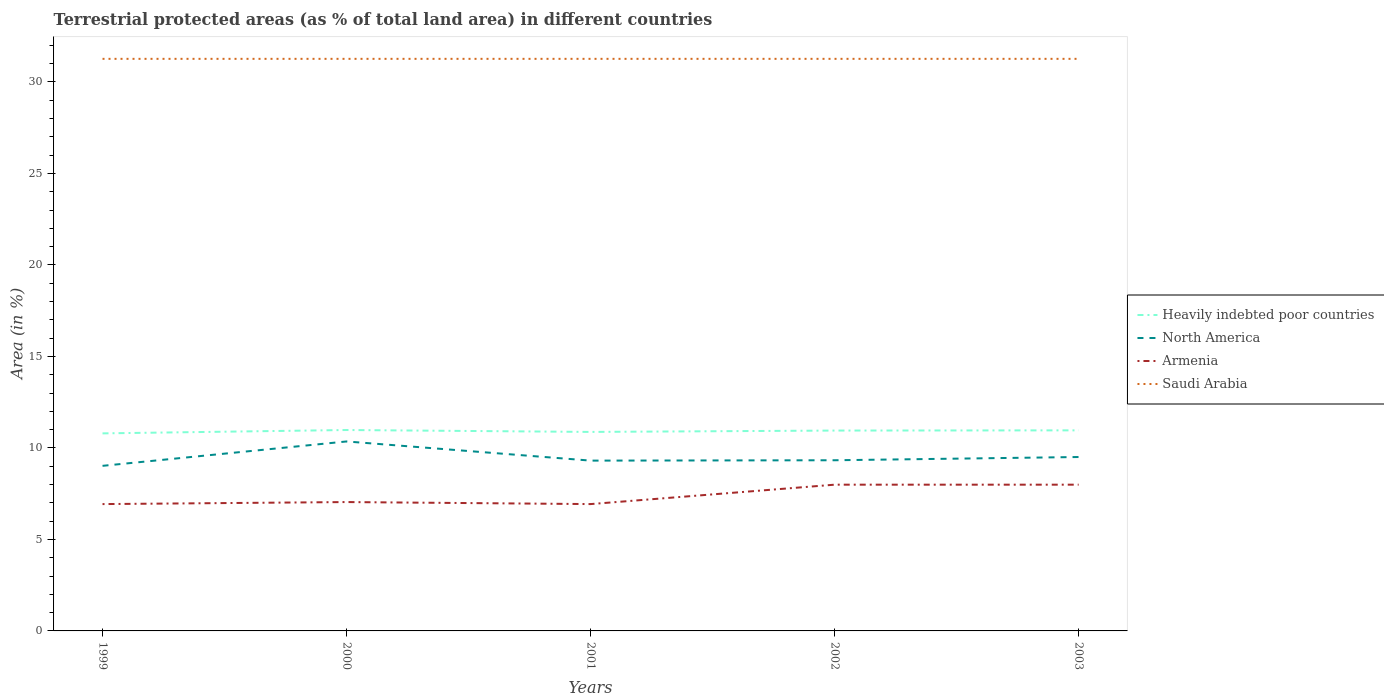Does the line corresponding to North America intersect with the line corresponding to Saudi Arabia?
Your answer should be compact. No. Across all years, what is the maximum percentage of terrestrial protected land in Saudi Arabia?
Provide a succinct answer. 31.26. What is the total percentage of terrestrial protected land in Saudi Arabia in the graph?
Offer a very short reply. 0. What is the difference between the highest and the second highest percentage of terrestrial protected land in Armenia?
Offer a very short reply. 1.06. Is the percentage of terrestrial protected land in Armenia strictly greater than the percentage of terrestrial protected land in Saudi Arabia over the years?
Ensure brevity in your answer.  Yes. How many years are there in the graph?
Provide a succinct answer. 5. Does the graph contain grids?
Your response must be concise. No. What is the title of the graph?
Your answer should be very brief. Terrestrial protected areas (as % of total land area) in different countries. Does "United Arab Emirates" appear as one of the legend labels in the graph?
Provide a succinct answer. No. What is the label or title of the Y-axis?
Provide a succinct answer. Area (in %). What is the Area (in %) in Heavily indebted poor countries in 1999?
Your answer should be compact. 10.8. What is the Area (in %) in North America in 1999?
Offer a terse response. 9.02. What is the Area (in %) of Armenia in 1999?
Provide a succinct answer. 6.93. What is the Area (in %) of Saudi Arabia in 1999?
Provide a short and direct response. 31.26. What is the Area (in %) in Heavily indebted poor countries in 2000?
Provide a succinct answer. 10.98. What is the Area (in %) in North America in 2000?
Provide a succinct answer. 10.35. What is the Area (in %) of Armenia in 2000?
Your answer should be very brief. 7.04. What is the Area (in %) in Saudi Arabia in 2000?
Your answer should be very brief. 31.26. What is the Area (in %) of Heavily indebted poor countries in 2001?
Your response must be concise. 10.87. What is the Area (in %) in North America in 2001?
Provide a short and direct response. 9.31. What is the Area (in %) of Armenia in 2001?
Keep it short and to the point. 6.93. What is the Area (in %) in Saudi Arabia in 2001?
Make the answer very short. 31.26. What is the Area (in %) in Heavily indebted poor countries in 2002?
Provide a succinct answer. 10.95. What is the Area (in %) of North America in 2002?
Ensure brevity in your answer.  9.33. What is the Area (in %) in Armenia in 2002?
Provide a short and direct response. 7.99. What is the Area (in %) of Saudi Arabia in 2002?
Ensure brevity in your answer.  31.26. What is the Area (in %) of Heavily indebted poor countries in 2003?
Keep it short and to the point. 10.96. What is the Area (in %) in North America in 2003?
Your response must be concise. 9.5. What is the Area (in %) of Armenia in 2003?
Your answer should be compact. 7.99. What is the Area (in %) of Saudi Arabia in 2003?
Your answer should be very brief. 31.26. Across all years, what is the maximum Area (in %) in Heavily indebted poor countries?
Provide a succinct answer. 10.98. Across all years, what is the maximum Area (in %) in North America?
Offer a very short reply. 10.35. Across all years, what is the maximum Area (in %) of Armenia?
Keep it short and to the point. 7.99. Across all years, what is the maximum Area (in %) in Saudi Arabia?
Make the answer very short. 31.26. Across all years, what is the minimum Area (in %) in Heavily indebted poor countries?
Your answer should be compact. 10.8. Across all years, what is the minimum Area (in %) in North America?
Make the answer very short. 9.02. Across all years, what is the minimum Area (in %) of Armenia?
Provide a succinct answer. 6.93. Across all years, what is the minimum Area (in %) in Saudi Arabia?
Your answer should be compact. 31.26. What is the total Area (in %) of Heavily indebted poor countries in the graph?
Offer a terse response. 54.56. What is the total Area (in %) of North America in the graph?
Give a very brief answer. 47.51. What is the total Area (in %) in Armenia in the graph?
Ensure brevity in your answer.  36.89. What is the total Area (in %) of Saudi Arabia in the graph?
Provide a succinct answer. 156.31. What is the difference between the Area (in %) of Heavily indebted poor countries in 1999 and that in 2000?
Give a very brief answer. -0.18. What is the difference between the Area (in %) of North America in 1999 and that in 2000?
Your answer should be very brief. -1.33. What is the difference between the Area (in %) of Armenia in 1999 and that in 2000?
Your answer should be very brief. -0.11. What is the difference between the Area (in %) of Saudi Arabia in 1999 and that in 2000?
Offer a terse response. -0. What is the difference between the Area (in %) in Heavily indebted poor countries in 1999 and that in 2001?
Your answer should be very brief. -0.08. What is the difference between the Area (in %) in North America in 1999 and that in 2001?
Ensure brevity in your answer.  -0.29. What is the difference between the Area (in %) of Armenia in 1999 and that in 2001?
Ensure brevity in your answer.  0. What is the difference between the Area (in %) in Heavily indebted poor countries in 1999 and that in 2002?
Provide a short and direct response. -0.15. What is the difference between the Area (in %) in North America in 1999 and that in 2002?
Offer a terse response. -0.31. What is the difference between the Area (in %) in Armenia in 1999 and that in 2002?
Make the answer very short. -1.06. What is the difference between the Area (in %) of Heavily indebted poor countries in 1999 and that in 2003?
Give a very brief answer. -0.17. What is the difference between the Area (in %) of North America in 1999 and that in 2003?
Give a very brief answer. -0.48. What is the difference between the Area (in %) of Armenia in 1999 and that in 2003?
Offer a terse response. -1.06. What is the difference between the Area (in %) of Heavily indebted poor countries in 2000 and that in 2001?
Provide a short and direct response. 0.1. What is the difference between the Area (in %) in North America in 2000 and that in 2001?
Keep it short and to the point. 1.05. What is the difference between the Area (in %) in Armenia in 2000 and that in 2001?
Ensure brevity in your answer.  0.11. What is the difference between the Area (in %) of Heavily indebted poor countries in 2000 and that in 2002?
Your response must be concise. 0.03. What is the difference between the Area (in %) in North America in 2000 and that in 2002?
Your answer should be very brief. 1.03. What is the difference between the Area (in %) of Armenia in 2000 and that in 2002?
Make the answer very short. -0.95. What is the difference between the Area (in %) in Heavily indebted poor countries in 2000 and that in 2003?
Give a very brief answer. 0.02. What is the difference between the Area (in %) of North America in 2000 and that in 2003?
Keep it short and to the point. 0.85. What is the difference between the Area (in %) of Armenia in 2000 and that in 2003?
Keep it short and to the point. -0.95. What is the difference between the Area (in %) of Heavily indebted poor countries in 2001 and that in 2002?
Your answer should be compact. -0.07. What is the difference between the Area (in %) in North America in 2001 and that in 2002?
Your answer should be compact. -0.02. What is the difference between the Area (in %) of Armenia in 2001 and that in 2002?
Provide a short and direct response. -1.06. What is the difference between the Area (in %) in Saudi Arabia in 2001 and that in 2002?
Keep it short and to the point. 0. What is the difference between the Area (in %) of Heavily indebted poor countries in 2001 and that in 2003?
Offer a very short reply. -0.09. What is the difference between the Area (in %) of North America in 2001 and that in 2003?
Give a very brief answer. -0.2. What is the difference between the Area (in %) of Armenia in 2001 and that in 2003?
Your answer should be compact. -1.06. What is the difference between the Area (in %) of Heavily indebted poor countries in 2002 and that in 2003?
Provide a short and direct response. -0.01. What is the difference between the Area (in %) in North America in 2002 and that in 2003?
Make the answer very short. -0.18. What is the difference between the Area (in %) of Heavily indebted poor countries in 1999 and the Area (in %) of North America in 2000?
Offer a terse response. 0.44. What is the difference between the Area (in %) of Heavily indebted poor countries in 1999 and the Area (in %) of Armenia in 2000?
Give a very brief answer. 3.75. What is the difference between the Area (in %) of Heavily indebted poor countries in 1999 and the Area (in %) of Saudi Arabia in 2000?
Provide a short and direct response. -20.47. What is the difference between the Area (in %) in North America in 1999 and the Area (in %) in Armenia in 2000?
Your response must be concise. 1.98. What is the difference between the Area (in %) of North America in 1999 and the Area (in %) of Saudi Arabia in 2000?
Make the answer very short. -22.24. What is the difference between the Area (in %) of Armenia in 1999 and the Area (in %) of Saudi Arabia in 2000?
Ensure brevity in your answer.  -24.33. What is the difference between the Area (in %) in Heavily indebted poor countries in 1999 and the Area (in %) in North America in 2001?
Give a very brief answer. 1.49. What is the difference between the Area (in %) of Heavily indebted poor countries in 1999 and the Area (in %) of Armenia in 2001?
Give a very brief answer. 3.86. What is the difference between the Area (in %) in Heavily indebted poor countries in 1999 and the Area (in %) in Saudi Arabia in 2001?
Make the answer very short. -20.47. What is the difference between the Area (in %) of North America in 1999 and the Area (in %) of Armenia in 2001?
Your answer should be very brief. 2.09. What is the difference between the Area (in %) of North America in 1999 and the Area (in %) of Saudi Arabia in 2001?
Provide a succinct answer. -22.24. What is the difference between the Area (in %) of Armenia in 1999 and the Area (in %) of Saudi Arabia in 2001?
Give a very brief answer. -24.33. What is the difference between the Area (in %) of Heavily indebted poor countries in 1999 and the Area (in %) of North America in 2002?
Ensure brevity in your answer.  1.47. What is the difference between the Area (in %) of Heavily indebted poor countries in 1999 and the Area (in %) of Armenia in 2002?
Make the answer very short. 2.8. What is the difference between the Area (in %) of Heavily indebted poor countries in 1999 and the Area (in %) of Saudi Arabia in 2002?
Give a very brief answer. -20.47. What is the difference between the Area (in %) in North America in 1999 and the Area (in %) in Armenia in 2002?
Your response must be concise. 1.03. What is the difference between the Area (in %) of North America in 1999 and the Area (in %) of Saudi Arabia in 2002?
Keep it short and to the point. -22.24. What is the difference between the Area (in %) of Armenia in 1999 and the Area (in %) of Saudi Arabia in 2002?
Your answer should be compact. -24.33. What is the difference between the Area (in %) of Heavily indebted poor countries in 1999 and the Area (in %) of North America in 2003?
Give a very brief answer. 1.29. What is the difference between the Area (in %) of Heavily indebted poor countries in 1999 and the Area (in %) of Armenia in 2003?
Your answer should be very brief. 2.8. What is the difference between the Area (in %) of Heavily indebted poor countries in 1999 and the Area (in %) of Saudi Arabia in 2003?
Provide a short and direct response. -20.47. What is the difference between the Area (in %) in North America in 1999 and the Area (in %) in Armenia in 2003?
Provide a succinct answer. 1.03. What is the difference between the Area (in %) in North America in 1999 and the Area (in %) in Saudi Arabia in 2003?
Make the answer very short. -22.24. What is the difference between the Area (in %) of Armenia in 1999 and the Area (in %) of Saudi Arabia in 2003?
Keep it short and to the point. -24.33. What is the difference between the Area (in %) in Heavily indebted poor countries in 2000 and the Area (in %) in North America in 2001?
Your response must be concise. 1.67. What is the difference between the Area (in %) of Heavily indebted poor countries in 2000 and the Area (in %) of Armenia in 2001?
Offer a very short reply. 4.05. What is the difference between the Area (in %) in Heavily indebted poor countries in 2000 and the Area (in %) in Saudi Arabia in 2001?
Keep it short and to the point. -20.28. What is the difference between the Area (in %) in North America in 2000 and the Area (in %) in Armenia in 2001?
Your answer should be very brief. 3.42. What is the difference between the Area (in %) of North America in 2000 and the Area (in %) of Saudi Arabia in 2001?
Offer a terse response. -20.91. What is the difference between the Area (in %) in Armenia in 2000 and the Area (in %) in Saudi Arabia in 2001?
Keep it short and to the point. -24.22. What is the difference between the Area (in %) in Heavily indebted poor countries in 2000 and the Area (in %) in North America in 2002?
Offer a very short reply. 1.65. What is the difference between the Area (in %) in Heavily indebted poor countries in 2000 and the Area (in %) in Armenia in 2002?
Make the answer very short. 2.99. What is the difference between the Area (in %) of Heavily indebted poor countries in 2000 and the Area (in %) of Saudi Arabia in 2002?
Make the answer very short. -20.28. What is the difference between the Area (in %) of North America in 2000 and the Area (in %) of Armenia in 2002?
Offer a terse response. 2.36. What is the difference between the Area (in %) of North America in 2000 and the Area (in %) of Saudi Arabia in 2002?
Your answer should be compact. -20.91. What is the difference between the Area (in %) of Armenia in 2000 and the Area (in %) of Saudi Arabia in 2002?
Ensure brevity in your answer.  -24.22. What is the difference between the Area (in %) of Heavily indebted poor countries in 2000 and the Area (in %) of North America in 2003?
Ensure brevity in your answer.  1.48. What is the difference between the Area (in %) of Heavily indebted poor countries in 2000 and the Area (in %) of Armenia in 2003?
Your response must be concise. 2.99. What is the difference between the Area (in %) of Heavily indebted poor countries in 2000 and the Area (in %) of Saudi Arabia in 2003?
Offer a very short reply. -20.28. What is the difference between the Area (in %) in North America in 2000 and the Area (in %) in Armenia in 2003?
Your response must be concise. 2.36. What is the difference between the Area (in %) in North America in 2000 and the Area (in %) in Saudi Arabia in 2003?
Provide a succinct answer. -20.91. What is the difference between the Area (in %) in Armenia in 2000 and the Area (in %) in Saudi Arabia in 2003?
Your response must be concise. -24.22. What is the difference between the Area (in %) of Heavily indebted poor countries in 2001 and the Area (in %) of North America in 2002?
Give a very brief answer. 1.55. What is the difference between the Area (in %) of Heavily indebted poor countries in 2001 and the Area (in %) of Armenia in 2002?
Provide a succinct answer. 2.88. What is the difference between the Area (in %) of Heavily indebted poor countries in 2001 and the Area (in %) of Saudi Arabia in 2002?
Keep it short and to the point. -20.39. What is the difference between the Area (in %) of North America in 2001 and the Area (in %) of Armenia in 2002?
Keep it short and to the point. 1.31. What is the difference between the Area (in %) of North America in 2001 and the Area (in %) of Saudi Arabia in 2002?
Make the answer very short. -21.96. What is the difference between the Area (in %) of Armenia in 2001 and the Area (in %) of Saudi Arabia in 2002?
Your answer should be compact. -24.33. What is the difference between the Area (in %) in Heavily indebted poor countries in 2001 and the Area (in %) in North America in 2003?
Provide a succinct answer. 1.37. What is the difference between the Area (in %) in Heavily indebted poor countries in 2001 and the Area (in %) in Armenia in 2003?
Offer a very short reply. 2.88. What is the difference between the Area (in %) in Heavily indebted poor countries in 2001 and the Area (in %) in Saudi Arabia in 2003?
Your response must be concise. -20.39. What is the difference between the Area (in %) in North America in 2001 and the Area (in %) in Armenia in 2003?
Provide a succinct answer. 1.31. What is the difference between the Area (in %) of North America in 2001 and the Area (in %) of Saudi Arabia in 2003?
Keep it short and to the point. -21.96. What is the difference between the Area (in %) in Armenia in 2001 and the Area (in %) in Saudi Arabia in 2003?
Provide a short and direct response. -24.33. What is the difference between the Area (in %) in Heavily indebted poor countries in 2002 and the Area (in %) in North America in 2003?
Ensure brevity in your answer.  1.45. What is the difference between the Area (in %) of Heavily indebted poor countries in 2002 and the Area (in %) of Armenia in 2003?
Keep it short and to the point. 2.96. What is the difference between the Area (in %) in Heavily indebted poor countries in 2002 and the Area (in %) in Saudi Arabia in 2003?
Give a very brief answer. -20.31. What is the difference between the Area (in %) of North America in 2002 and the Area (in %) of Armenia in 2003?
Your response must be concise. 1.33. What is the difference between the Area (in %) of North America in 2002 and the Area (in %) of Saudi Arabia in 2003?
Offer a very short reply. -21.94. What is the difference between the Area (in %) of Armenia in 2002 and the Area (in %) of Saudi Arabia in 2003?
Keep it short and to the point. -23.27. What is the average Area (in %) of Heavily indebted poor countries per year?
Your answer should be very brief. 10.91. What is the average Area (in %) in North America per year?
Make the answer very short. 9.5. What is the average Area (in %) in Armenia per year?
Ensure brevity in your answer.  7.38. What is the average Area (in %) in Saudi Arabia per year?
Offer a very short reply. 31.26. In the year 1999, what is the difference between the Area (in %) of Heavily indebted poor countries and Area (in %) of North America?
Your answer should be compact. 1.77. In the year 1999, what is the difference between the Area (in %) in Heavily indebted poor countries and Area (in %) in Armenia?
Provide a succinct answer. 3.86. In the year 1999, what is the difference between the Area (in %) in Heavily indebted poor countries and Area (in %) in Saudi Arabia?
Offer a very short reply. -20.47. In the year 1999, what is the difference between the Area (in %) in North America and Area (in %) in Armenia?
Provide a succinct answer. 2.09. In the year 1999, what is the difference between the Area (in %) of North America and Area (in %) of Saudi Arabia?
Make the answer very short. -22.24. In the year 1999, what is the difference between the Area (in %) of Armenia and Area (in %) of Saudi Arabia?
Offer a very short reply. -24.33. In the year 2000, what is the difference between the Area (in %) in Heavily indebted poor countries and Area (in %) in North America?
Provide a short and direct response. 0.63. In the year 2000, what is the difference between the Area (in %) of Heavily indebted poor countries and Area (in %) of Armenia?
Provide a short and direct response. 3.94. In the year 2000, what is the difference between the Area (in %) in Heavily indebted poor countries and Area (in %) in Saudi Arabia?
Offer a very short reply. -20.28. In the year 2000, what is the difference between the Area (in %) in North America and Area (in %) in Armenia?
Make the answer very short. 3.31. In the year 2000, what is the difference between the Area (in %) in North America and Area (in %) in Saudi Arabia?
Provide a short and direct response. -20.91. In the year 2000, what is the difference between the Area (in %) in Armenia and Area (in %) in Saudi Arabia?
Your response must be concise. -24.22. In the year 2001, what is the difference between the Area (in %) of Heavily indebted poor countries and Area (in %) of North America?
Your answer should be compact. 1.57. In the year 2001, what is the difference between the Area (in %) in Heavily indebted poor countries and Area (in %) in Armenia?
Give a very brief answer. 3.94. In the year 2001, what is the difference between the Area (in %) in Heavily indebted poor countries and Area (in %) in Saudi Arabia?
Offer a very short reply. -20.39. In the year 2001, what is the difference between the Area (in %) in North America and Area (in %) in Armenia?
Offer a very short reply. 2.38. In the year 2001, what is the difference between the Area (in %) of North America and Area (in %) of Saudi Arabia?
Provide a short and direct response. -21.96. In the year 2001, what is the difference between the Area (in %) of Armenia and Area (in %) of Saudi Arabia?
Provide a succinct answer. -24.33. In the year 2002, what is the difference between the Area (in %) in Heavily indebted poor countries and Area (in %) in North America?
Ensure brevity in your answer.  1.62. In the year 2002, what is the difference between the Area (in %) of Heavily indebted poor countries and Area (in %) of Armenia?
Provide a short and direct response. 2.96. In the year 2002, what is the difference between the Area (in %) of Heavily indebted poor countries and Area (in %) of Saudi Arabia?
Give a very brief answer. -20.31. In the year 2002, what is the difference between the Area (in %) in North America and Area (in %) in Armenia?
Keep it short and to the point. 1.33. In the year 2002, what is the difference between the Area (in %) of North America and Area (in %) of Saudi Arabia?
Offer a terse response. -21.94. In the year 2002, what is the difference between the Area (in %) in Armenia and Area (in %) in Saudi Arabia?
Your response must be concise. -23.27. In the year 2003, what is the difference between the Area (in %) of Heavily indebted poor countries and Area (in %) of North America?
Offer a very short reply. 1.46. In the year 2003, what is the difference between the Area (in %) of Heavily indebted poor countries and Area (in %) of Armenia?
Ensure brevity in your answer.  2.97. In the year 2003, what is the difference between the Area (in %) in Heavily indebted poor countries and Area (in %) in Saudi Arabia?
Offer a very short reply. -20.3. In the year 2003, what is the difference between the Area (in %) in North America and Area (in %) in Armenia?
Offer a very short reply. 1.51. In the year 2003, what is the difference between the Area (in %) in North America and Area (in %) in Saudi Arabia?
Keep it short and to the point. -21.76. In the year 2003, what is the difference between the Area (in %) in Armenia and Area (in %) in Saudi Arabia?
Offer a terse response. -23.27. What is the ratio of the Area (in %) in Heavily indebted poor countries in 1999 to that in 2000?
Keep it short and to the point. 0.98. What is the ratio of the Area (in %) in North America in 1999 to that in 2000?
Ensure brevity in your answer.  0.87. What is the ratio of the Area (in %) of Armenia in 1999 to that in 2000?
Ensure brevity in your answer.  0.98. What is the ratio of the Area (in %) of North America in 1999 to that in 2001?
Provide a short and direct response. 0.97. What is the ratio of the Area (in %) in Armenia in 1999 to that in 2001?
Offer a terse response. 1. What is the ratio of the Area (in %) of Saudi Arabia in 1999 to that in 2001?
Provide a succinct answer. 1. What is the ratio of the Area (in %) in Heavily indebted poor countries in 1999 to that in 2002?
Give a very brief answer. 0.99. What is the ratio of the Area (in %) in North America in 1999 to that in 2002?
Keep it short and to the point. 0.97. What is the ratio of the Area (in %) in Armenia in 1999 to that in 2002?
Your answer should be compact. 0.87. What is the ratio of the Area (in %) of Saudi Arabia in 1999 to that in 2002?
Give a very brief answer. 1. What is the ratio of the Area (in %) of Heavily indebted poor countries in 1999 to that in 2003?
Provide a succinct answer. 0.98. What is the ratio of the Area (in %) of North America in 1999 to that in 2003?
Ensure brevity in your answer.  0.95. What is the ratio of the Area (in %) in Armenia in 1999 to that in 2003?
Your answer should be very brief. 0.87. What is the ratio of the Area (in %) in Heavily indebted poor countries in 2000 to that in 2001?
Your answer should be compact. 1.01. What is the ratio of the Area (in %) in North America in 2000 to that in 2001?
Give a very brief answer. 1.11. What is the ratio of the Area (in %) in North America in 2000 to that in 2002?
Ensure brevity in your answer.  1.11. What is the ratio of the Area (in %) of Armenia in 2000 to that in 2002?
Your answer should be very brief. 0.88. What is the ratio of the Area (in %) of North America in 2000 to that in 2003?
Give a very brief answer. 1.09. What is the ratio of the Area (in %) in Armenia in 2000 to that in 2003?
Offer a terse response. 0.88. What is the ratio of the Area (in %) of Saudi Arabia in 2000 to that in 2003?
Make the answer very short. 1. What is the ratio of the Area (in %) of North America in 2001 to that in 2002?
Provide a short and direct response. 1. What is the ratio of the Area (in %) of Armenia in 2001 to that in 2002?
Ensure brevity in your answer.  0.87. What is the ratio of the Area (in %) in Saudi Arabia in 2001 to that in 2002?
Keep it short and to the point. 1. What is the ratio of the Area (in %) in Heavily indebted poor countries in 2001 to that in 2003?
Offer a terse response. 0.99. What is the ratio of the Area (in %) in North America in 2001 to that in 2003?
Offer a very short reply. 0.98. What is the ratio of the Area (in %) in Armenia in 2001 to that in 2003?
Offer a terse response. 0.87. What is the ratio of the Area (in %) in Heavily indebted poor countries in 2002 to that in 2003?
Offer a terse response. 1. What is the ratio of the Area (in %) of North America in 2002 to that in 2003?
Offer a terse response. 0.98. What is the difference between the highest and the second highest Area (in %) of Heavily indebted poor countries?
Give a very brief answer. 0.02. What is the difference between the highest and the second highest Area (in %) of North America?
Your response must be concise. 0.85. What is the difference between the highest and the second highest Area (in %) in Armenia?
Make the answer very short. 0. What is the difference between the highest and the second highest Area (in %) in Saudi Arabia?
Give a very brief answer. 0. What is the difference between the highest and the lowest Area (in %) in Heavily indebted poor countries?
Offer a very short reply. 0.18. What is the difference between the highest and the lowest Area (in %) in North America?
Your answer should be very brief. 1.33. What is the difference between the highest and the lowest Area (in %) of Armenia?
Ensure brevity in your answer.  1.06. 